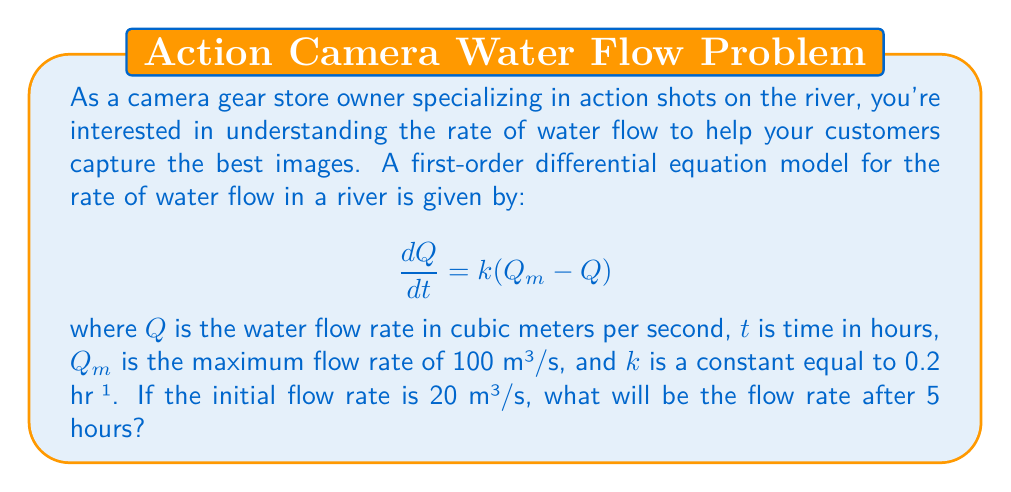Can you answer this question? To solve this problem, we need to use the given first-order differential equation and initial condition:

1) The differential equation is: $\frac{dQ}{dt} = k(Q_m - Q)$

2) We're given:
   $k = 0.2$ hr⁻¹
   $Q_m = 100$ m³/s
   Initial condition: $Q(0) = 20$ m³/s
   We need to find $Q(5)$

3) This is a separable differential equation. Let's solve it:

   $\frac{dQ}{Q_m - Q} = k dt$

4) Integrating both sides:

   $-\ln|Q_m - Q| = kt + C$

5) Applying the initial condition $Q(0) = 20$:

   $-\ln|100 - 20| = 0 + C$
   $-\ln(80) = C$

6) Substituting back:

   $-\ln|100 - Q| = 0.2t - \ln(80)$

7) Solving for Q:

   $\ln|100 - Q| = \ln(80) - 0.2t$
   $|100 - Q| = 80e^{-0.2t}$
   $100 - Q = 80e^{-0.2t}$ (since Q < 100)
   $Q = 100 - 80e^{-0.2t}$

8) Now we can find Q(5):

   $Q(5) = 100 - 80e^{-0.2(5)}$
   $= 100 - 80e^{-1}$
   $\approx 70.6$ m³/s
Answer: The flow rate after 5 hours will be approximately 70.6 m³/s. 